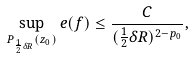Convert formula to latex. <formula><loc_0><loc_0><loc_500><loc_500>\sup _ { P _ { \frac { 1 } { 2 } \delta R } ( z _ { 0 } ) } e ( f ) \leq \frac { C } { ( \frac { 1 } { 2 } \delta R ) ^ { 2 - p _ { 0 } } } ,</formula> 